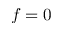<formula> <loc_0><loc_0><loc_500><loc_500>f = 0</formula> 